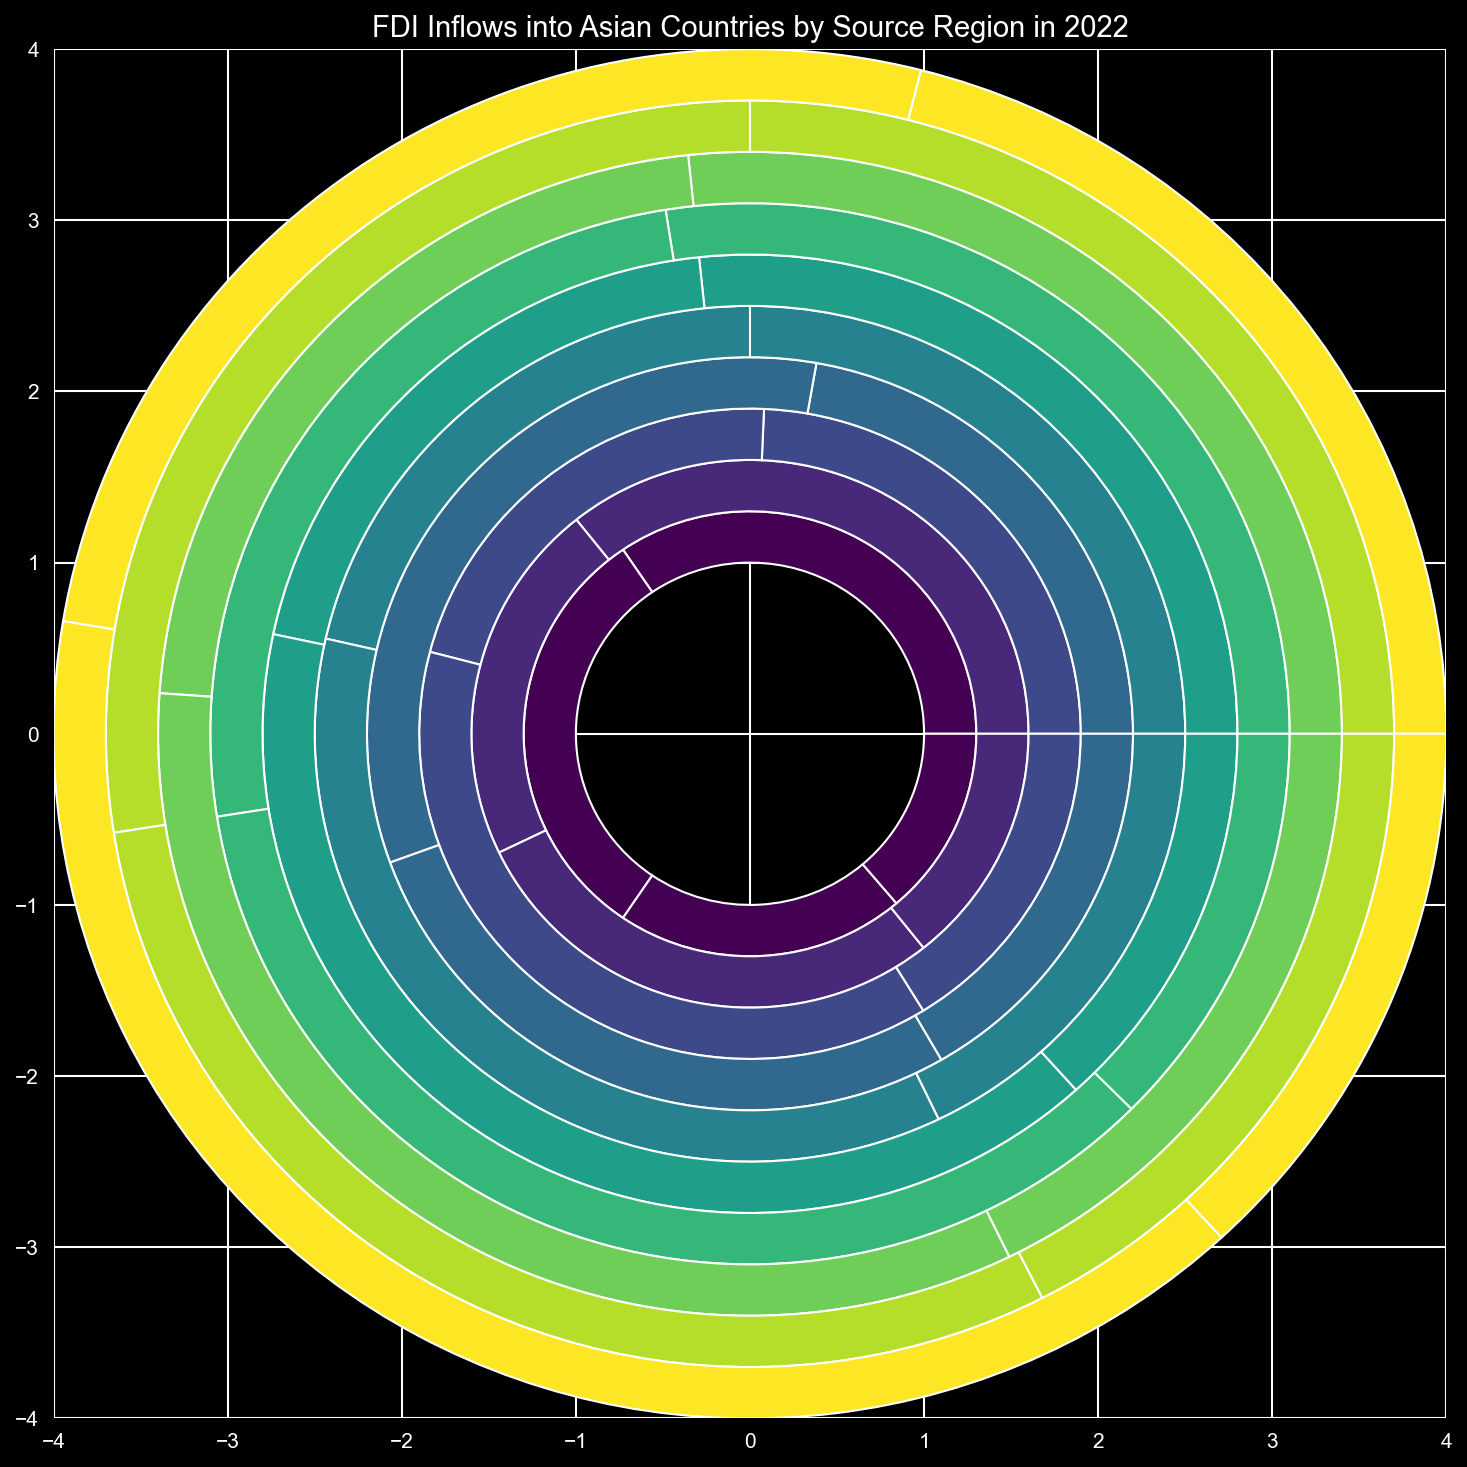Which country received the highest total FDI inflows in 2022? Look for the country section with the largest visual area in the ring chart. Sum up the inflows for each country and compare.
Answer: China What fraction of Japan's FDI inflows came from Europe? Identify Japan's section in the ring chart. Within this section, visually compare the slice representing Europe to the whole section for Japan. Calculate Europe inflow / Total Japan inflows= 30000 / (20000 + 30000 + 25000 + 15000).
Answer: 30/90 = 1/3 or approx. 33.3% Compare the FDI inflows from North America to South Korea and Vietnam. Which country received more? Locate the sections for South Korea and Vietnam. Then, compare the slices for North American inflows by visually comparing their sizes. South Korea's North American inflows: 12000, Vietnam's North American inflows: 8000.
Answer: South Korea Among the countries listed, which one has the smallest proportion of its FDI inflows coming from 'Other Regions'? For each country, find the 'Other Regions' section and visually assess its proportion relative to the entire country section. Compare numeric values.
Answer: Philippines Calculate the total FDI inflows from North America across all listed countries. Sum all the slices in the North America section for each country. The numeric values are: 50000 + 25000 + 20000 + 12000 + 22000 + 8000 + 10000 + 9000 + 7000 + 4000. Total inflows = 189000.
Answer: 189000 How does the total FDI inflows from Asia into India compare to those from Europe into China? Look at the FDI inflows from Asia and Europe into India and China respectively. India's Asia inflow: 20000. China's Europe inflow: 45000.
Answer: China's inflow from Europe is greater Which region contributes the most FDI to Singapore? Locate Singapore's section in the chart and identify which inflows slice is largest. Compare North America, Europe, Asia, and Other Region slices. Asia inflow: 28000.
Answer: Asia What is the difference between total FDI inflows into China and India? Calculate the total FDI inflows for China (50000 + 45000 + 30000 + 20000 = 145000) and India (25000 + 15000 + 20000 + 10000 = 70000). Then, subtract India's total from China's total.
Answer: 145000 - 70000 = 75000 Compare FDI inflows from Europe to Malaysia and Indonesia. Which one has larger inflows and by how much? Locate Europe inflows for Malaysia and Indonesia in their respective sections. Malaysia's Europe inflow: 6000, Indonesia's Europe inflow: 8000. Subtract Malaysia's Europe inflow from Indonesia's Europe inflow.
Answer: Indonesia by 2000 Which country has an equal FDI inflow contribution from both North America and Asia? Look for equivalent visual slices of North America and Asia within a country's section. Verify by checking the numeric values. Both inflows for Thailand are equal: 10000.
Answer: Thailand 